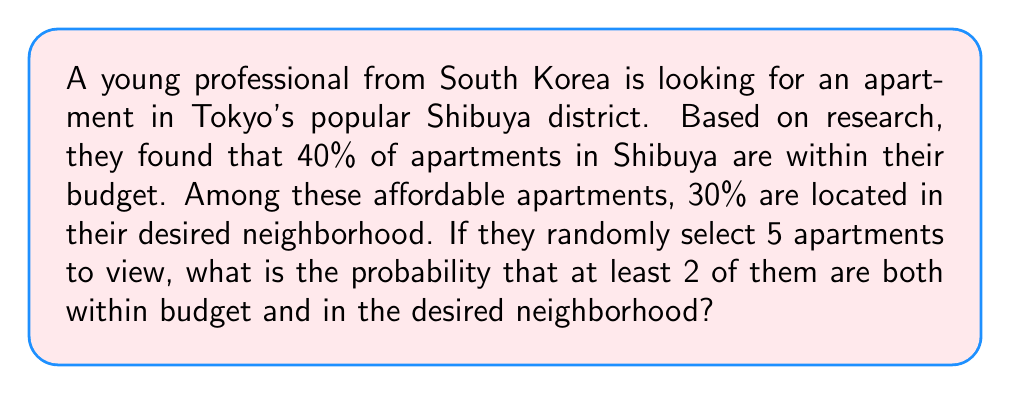Can you answer this question? Let's approach this step-by-step:

1) First, we need to calculate the probability of an apartment being both within budget and in the desired neighborhood:
   $P(\text{within budget and desired location}) = 0.40 \times 0.30 = 0.12 = 12\%$

2) Let $X$ be the number of apartments that are both within budget and in the desired neighborhood out of the 5 viewed. $X$ follows a binomial distribution with $n=5$ and $p=0.12$.

3) We want to find $P(X \geq 2)$, which is equivalent to $1 - P(X < 2) = 1 - [P(X=0) + P(X=1)]$

4) The probability mass function for a binomial distribution is:
   $P(X=k) = \binom{n}{k} p^k (1-p)^{n-k}$

5) Let's calculate $P(X=0)$ and $P(X=1)$:

   $P(X=0) = \binom{5}{0} (0.12)^0 (0.88)^5 = 1 \times 1 \times 0.88^5 \approx 0.5404$

   $P(X=1) = \binom{5}{1} (0.12)^1 (0.88)^4 = 5 \times 0.12 \times 0.88^4 \approx 0.3679$

6) Therefore:
   $P(X \geq 2) = 1 - [P(X=0) + P(X=1)] = 1 - (0.5404 + 0.3679) = 1 - 0.9083 = 0.0917$
Answer: The probability that at least 2 out of 5 randomly selected apartments are both within budget and in the desired neighborhood is approximately $0.0917$ or $9.17\%$. 